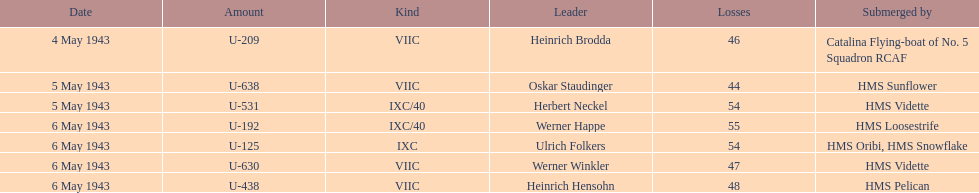Give me the full table as a dictionary. {'header': ['Date', 'Amount', 'Kind', 'Leader', 'Losses', 'Submerged by'], 'rows': [['4 May 1943', 'U-209', 'VIIC', 'Heinrich Brodda', '46', 'Catalina Flying-boat of No. 5 Squadron RCAF'], ['5 May 1943', 'U-638', 'VIIC', 'Oskar Staudinger', '44', 'HMS Sunflower'], ['5 May 1943', 'U-531', 'IXC/40', 'Herbert Neckel', '54', 'HMS Vidette'], ['6 May 1943', 'U-192', 'IXC/40', 'Werner Happe', '55', 'HMS Loosestrife'], ['6 May 1943', 'U-125', 'IXC', 'Ulrich Folkers', '54', 'HMS Oribi, HMS Snowflake'], ['6 May 1943', 'U-630', 'VIIC', 'Werner Winkler', '47', 'HMS Vidette'], ['6 May 1943', 'U-438', 'VIIC', 'Heinrich Hensohn', '48', 'HMS Pelican']]} How many more casualties occurred on may 6 compared to may 4? 158. 